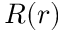Convert formula to latex. <formula><loc_0><loc_0><loc_500><loc_500>R ( r )</formula> 